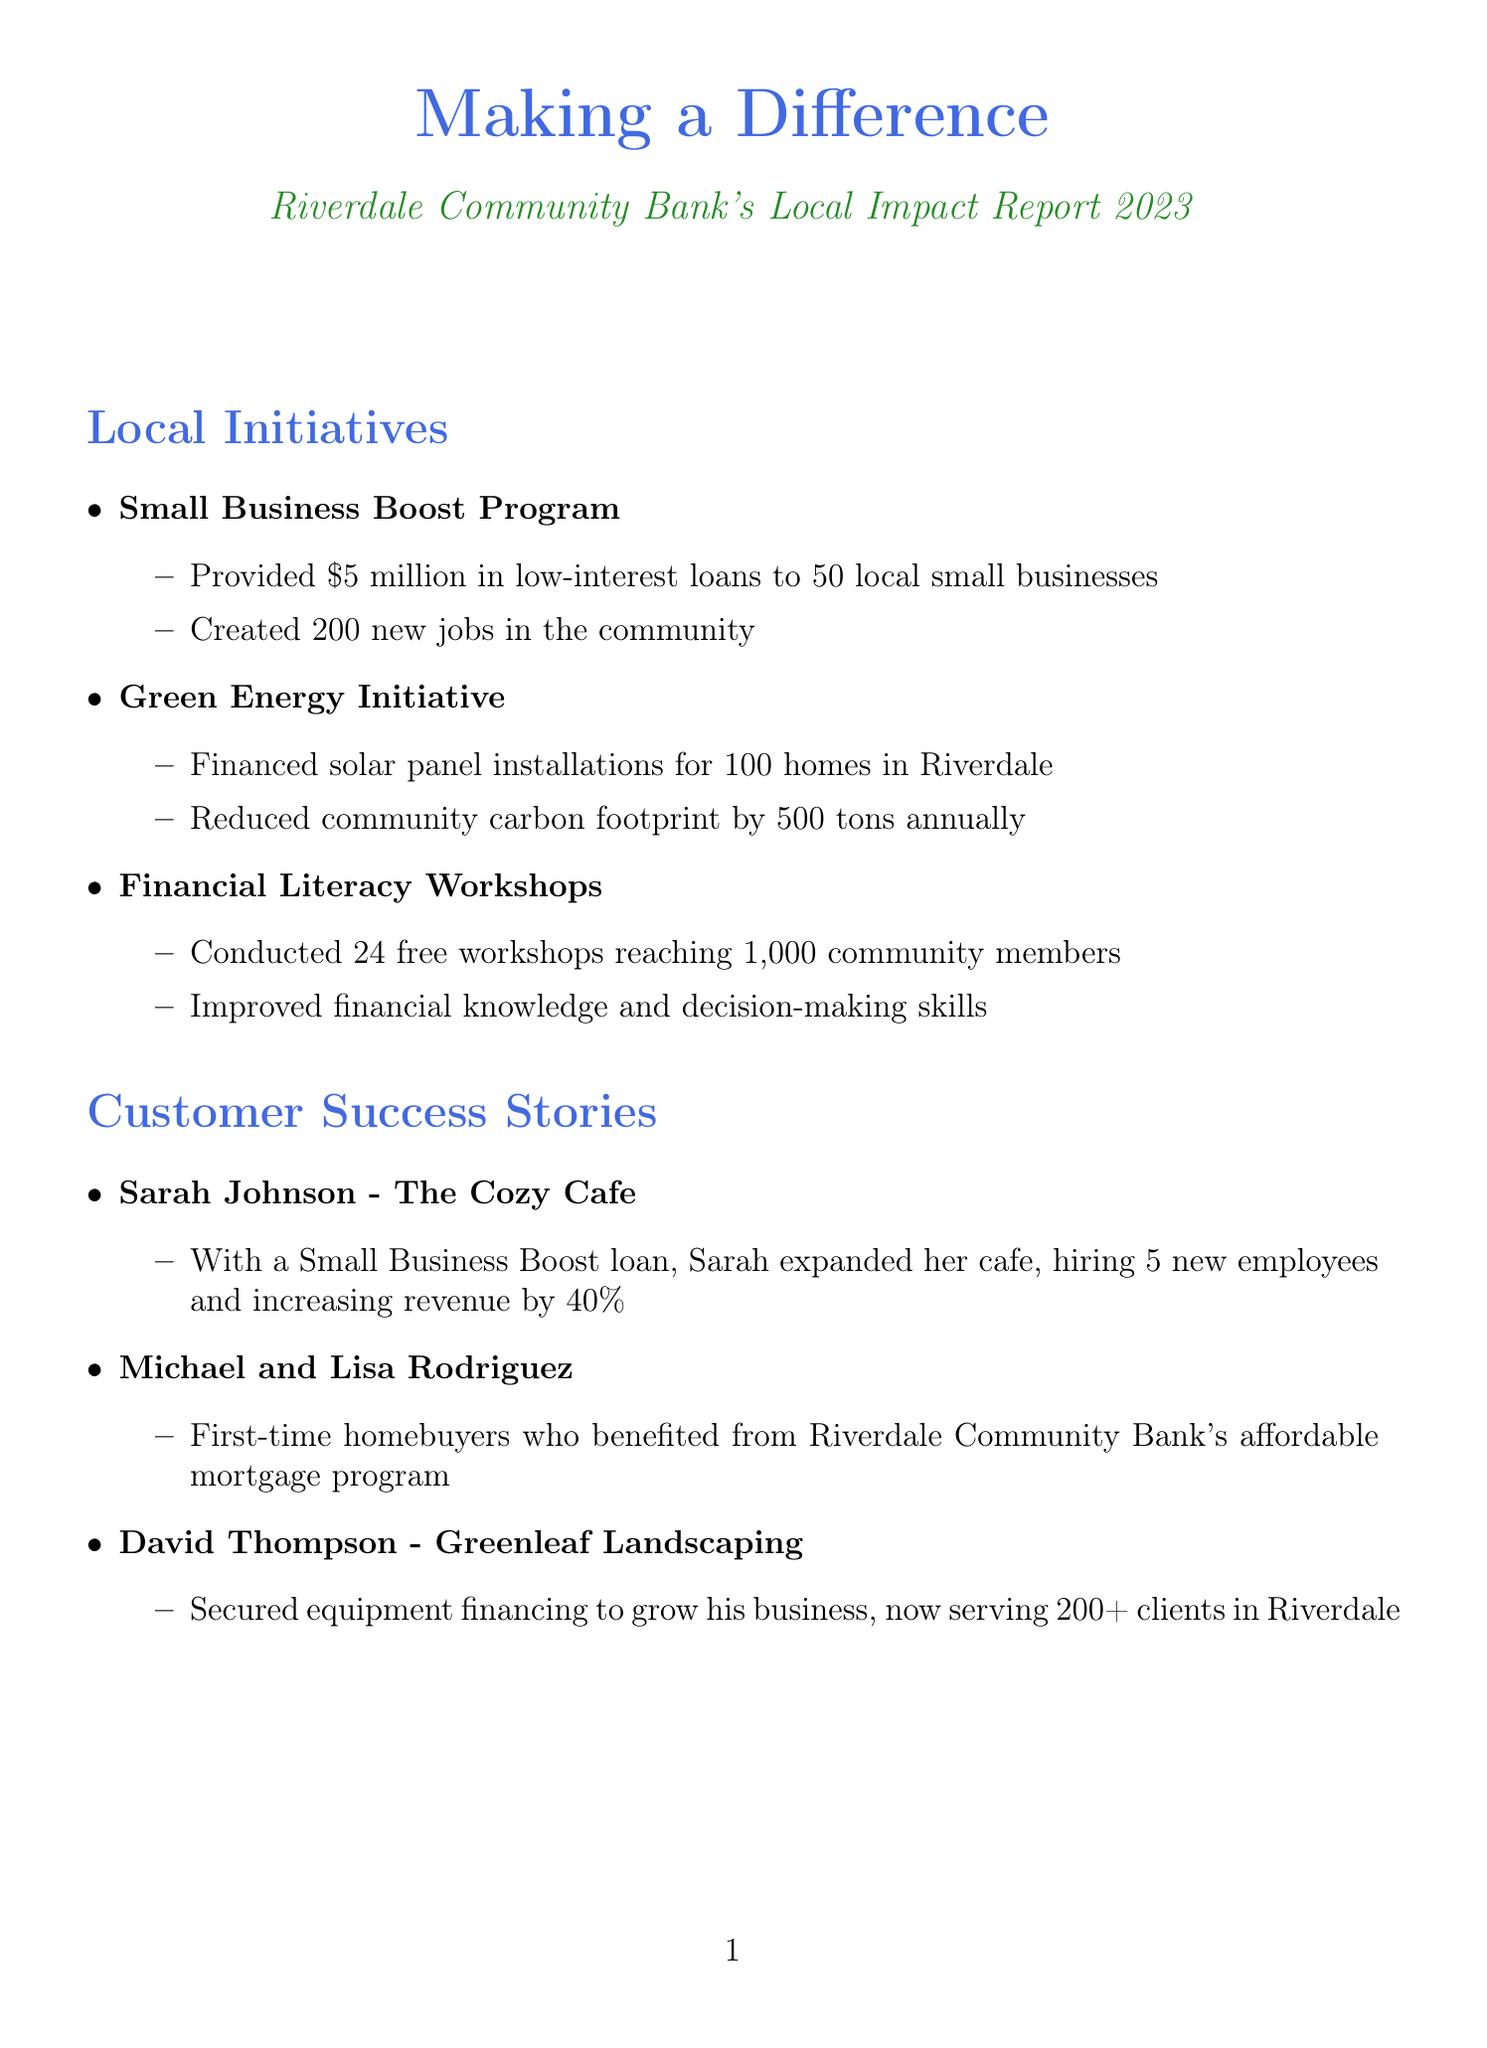What is the bank's total community investment? The total community investment is clearly stated in the financial highlights section of the document.
Answer: $10 million How many new accounts were opened? The number of new accounts opened is also mentioned in the financial highlights section.
Answer: 2,500 What initiative financed solar panel installations? The document specifies the initiative that supported solar panel installations for homes in Riverdale.
Answer: Green Energy Initiative Who is the owner of Greenleaf Landscaping? The document explicitly states the owner of Greenleaf Landscaping in the customer success stories section.
Answer: David Thompson How many free financial literacy workshops were conducted? The document provides the exact number of free workshops that were held in the local initiatives section.
Answer: 24 What was the customer satisfaction rate? The customer satisfaction rate is highlighted in the financial highlights section of the document.
Answer: 95% What is one future goal of the bank? The document lists several future goals of the bank; one of them can be easily identified.
Answer: Increase small business lending by 25% in the next year How much food was collected for local families? The initiative involving the Riverdale Food Bank for food collection is detailed in the community partnerships section.
Answer: 10,000 lbs Which customer expanded their cafe with a loan? The customer success stories provide a specific example of a customer who expanded her business using a loan.
Answer: Sarah Johnson 